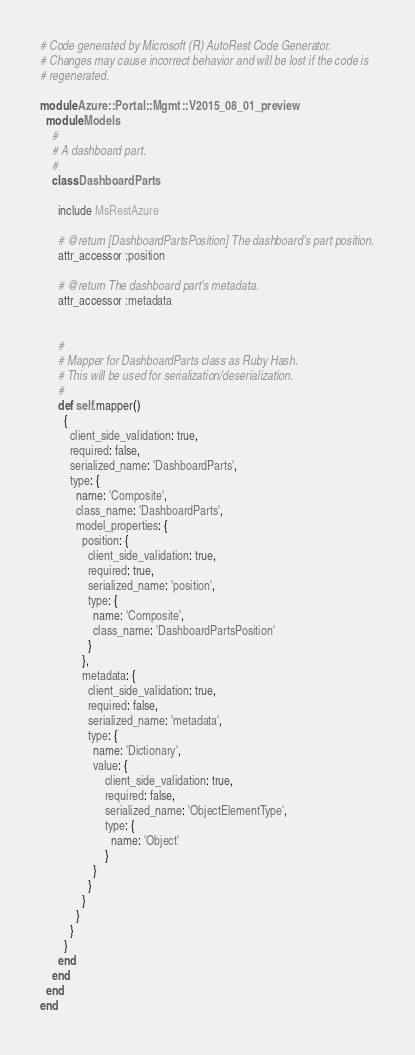<code> <loc_0><loc_0><loc_500><loc_500><_Ruby_># Code generated by Microsoft (R) AutoRest Code Generator.
# Changes may cause incorrect behavior and will be lost if the code is
# regenerated.

module Azure::Portal::Mgmt::V2015_08_01_preview
  module Models
    #
    # A dashboard part.
    #
    class DashboardParts

      include MsRestAzure

      # @return [DashboardPartsPosition] The dashboard's part position.
      attr_accessor :position

      # @return The dashboard part's metadata.
      attr_accessor :metadata


      #
      # Mapper for DashboardParts class as Ruby Hash.
      # This will be used for serialization/deserialization.
      #
      def self.mapper()
        {
          client_side_validation: true,
          required: false,
          serialized_name: 'DashboardParts',
          type: {
            name: 'Composite',
            class_name: 'DashboardParts',
            model_properties: {
              position: {
                client_side_validation: true,
                required: true,
                serialized_name: 'position',
                type: {
                  name: 'Composite',
                  class_name: 'DashboardPartsPosition'
                }
              },
              metadata: {
                client_side_validation: true,
                required: false,
                serialized_name: 'metadata',
                type: {
                  name: 'Dictionary',
                  value: {
                      client_side_validation: true,
                      required: false,
                      serialized_name: 'ObjectElementType',
                      type: {
                        name: 'Object'
                      }
                  }
                }
              }
            }
          }
        }
      end
    end
  end
end
</code> 